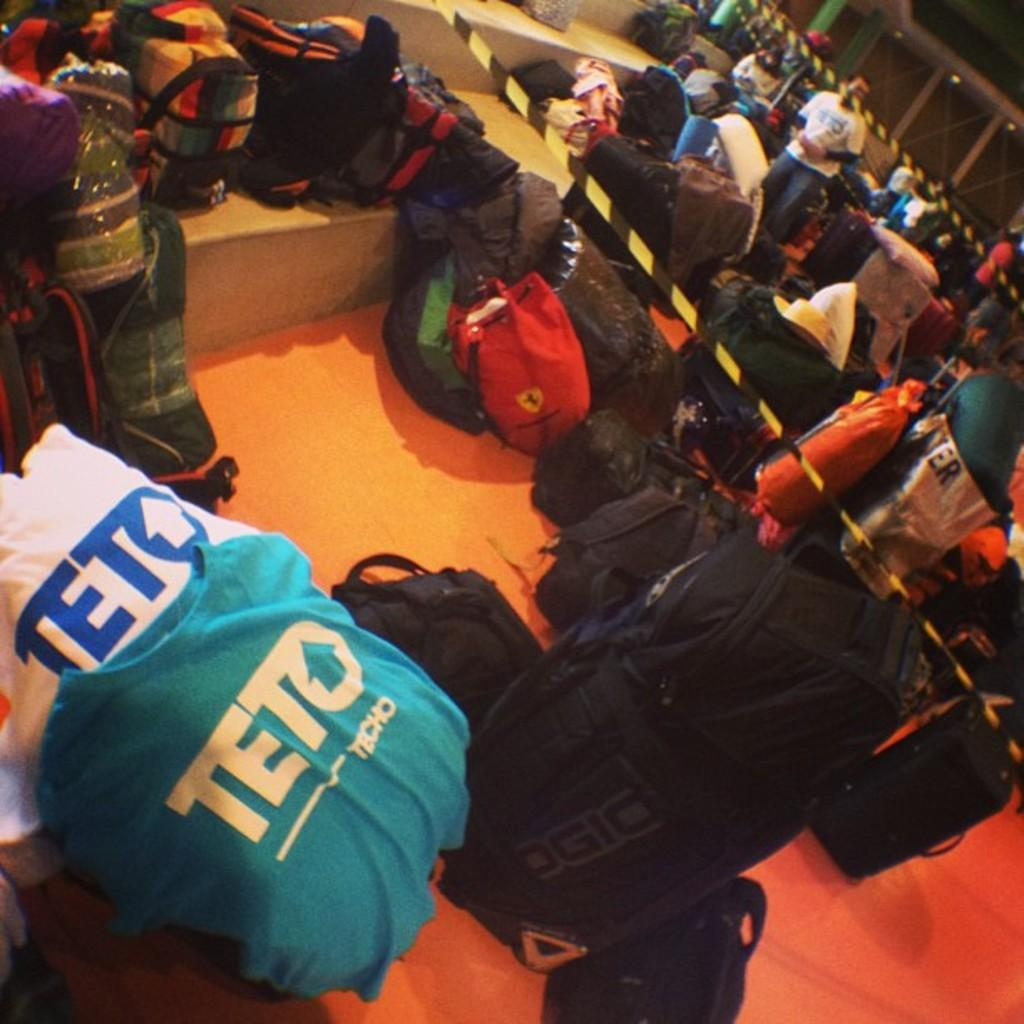<image>
Render a clear and concise summary of the photo. The Teto shirts are sitting around a stack of backpacks. 